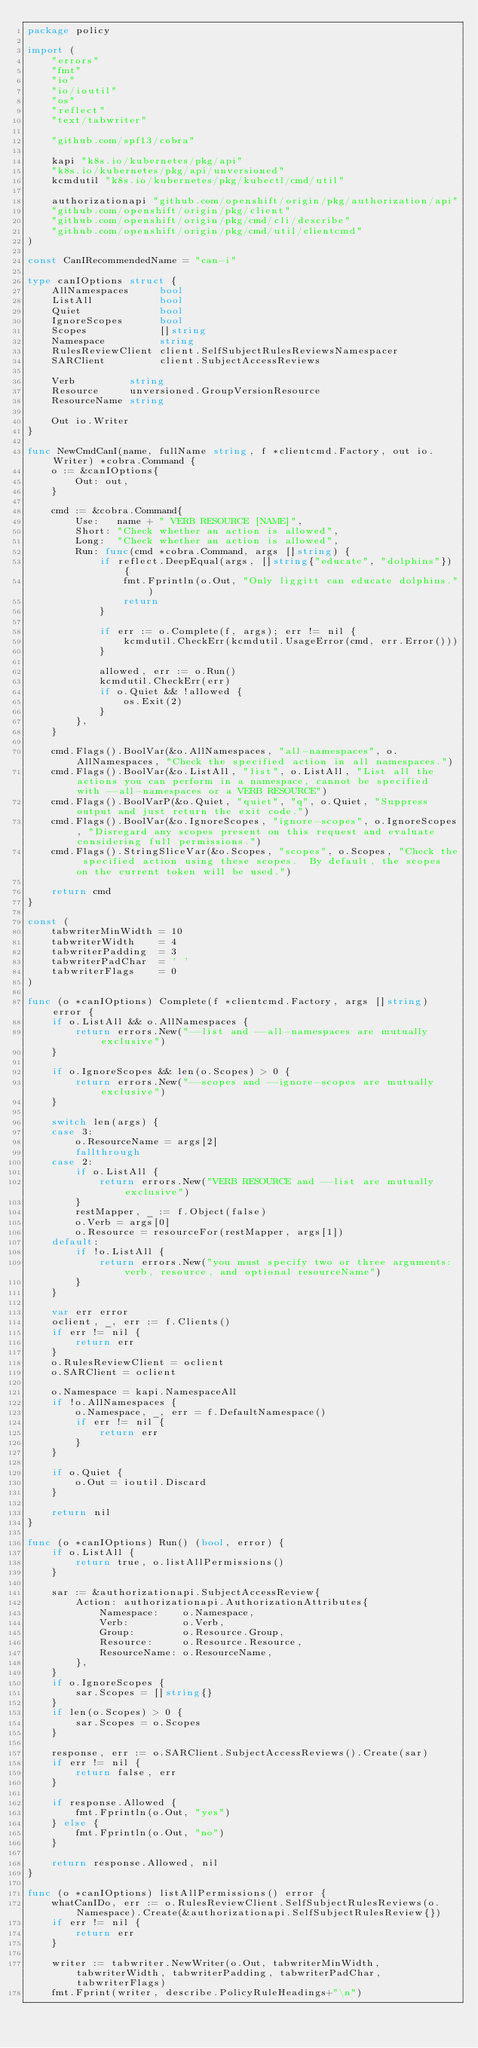<code> <loc_0><loc_0><loc_500><loc_500><_Go_>package policy

import (
	"errors"
	"fmt"
	"io"
	"io/ioutil"
	"os"
	"reflect"
	"text/tabwriter"

	"github.com/spf13/cobra"

	kapi "k8s.io/kubernetes/pkg/api"
	"k8s.io/kubernetes/pkg/api/unversioned"
	kcmdutil "k8s.io/kubernetes/pkg/kubectl/cmd/util"

	authorizationapi "github.com/openshift/origin/pkg/authorization/api"
	"github.com/openshift/origin/pkg/client"
	"github.com/openshift/origin/pkg/cmd/cli/describe"
	"github.com/openshift/origin/pkg/cmd/util/clientcmd"
)

const CanIRecommendedName = "can-i"

type canIOptions struct {
	AllNamespaces     bool
	ListAll           bool
	Quiet             bool
	IgnoreScopes      bool
	Scopes            []string
	Namespace         string
	RulesReviewClient client.SelfSubjectRulesReviewsNamespacer
	SARClient         client.SubjectAccessReviews

	Verb         string
	Resource     unversioned.GroupVersionResource
	ResourceName string

	Out io.Writer
}

func NewCmdCanI(name, fullName string, f *clientcmd.Factory, out io.Writer) *cobra.Command {
	o := &canIOptions{
		Out: out,
	}

	cmd := &cobra.Command{
		Use:   name + " VERB RESOURCE [NAME]",
		Short: "Check whether an action is allowed",
		Long:  "Check whether an action is allowed",
		Run: func(cmd *cobra.Command, args []string) {
			if reflect.DeepEqual(args, []string{"educate", "dolphins"}) {
				fmt.Fprintln(o.Out, "Only liggitt can educate dolphins.")
				return
			}

			if err := o.Complete(f, args); err != nil {
				kcmdutil.CheckErr(kcmdutil.UsageError(cmd, err.Error()))
			}

			allowed, err := o.Run()
			kcmdutil.CheckErr(err)
			if o.Quiet && !allowed {
				os.Exit(2)
			}
		},
	}

	cmd.Flags().BoolVar(&o.AllNamespaces, "all-namespaces", o.AllNamespaces, "Check the specified action in all namespaces.")
	cmd.Flags().BoolVar(&o.ListAll, "list", o.ListAll, "List all the actions you can perform in a namespace, cannot be specified with --all-namespaces or a VERB RESOURCE")
	cmd.Flags().BoolVarP(&o.Quiet, "quiet", "q", o.Quiet, "Suppress output and just return the exit code.")
	cmd.Flags().BoolVar(&o.IgnoreScopes, "ignore-scopes", o.IgnoreScopes, "Disregard any scopes present on this request and evaluate considering full permissions.")
	cmd.Flags().StringSliceVar(&o.Scopes, "scopes", o.Scopes, "Check the specified action using these scopes.  By default, the scopes on the current token will be used.")

	return cmd
}

const (
	tabwriterMinWidth = 10
	tabwriterWidth    = 4
	tabwriterPadding  = 3
	tabwriterPadChar  = ' '
	tabwriterFlags    = 0
)

func (o *canIOptions) Complete(f *clientcmd.Factory, args []string) error {
	if o.ListAll && o.AllNamespaces {
		return errors.New("--list and --all-namespaces are mutually exclusive")
	}

	if o.IgnoreScopes && len(o.Scopes) > 0 {
		return errors.New("--scopes and --ignore-scopes are mutually exclusive")
	}

	switch len(args) {
	case 3:
		o.ResourceName = args[2]
		fallthrough
	case 2:
		if o.ListAll {
			return errors.New("VERB RESOURCE and --list are mutually exclusive")
		}
		restMapper, _ := f.Object(false)
		o.Verb = args[0]
		o.Resource = resourceFor(restMapper, args[1])
	default:
		if !o.ListAll {
			return errors.New("you must specify two or three arguments: verb, resource, and optional resourceName")
		}
	}

	var err error
	oclient, _, err := f.Clients()
	if err != nil {
		return err
	}
	o.RulesReviewClient = oclient
	o.SARClient = oclient

	o.Namespace = kapi.NamespaceAll
	if !o.AllNamespaces {
		o.Namespace, _, err = f.DefaultNamespace()
		if err != nil {
			return err
		}
	}

	if o.Quiet {
		o.Out = ioutil.Discard
	}

	return nil
}

func (o *canIOptions) Run() (bool, error) {
	if o.ListAll {
		return true, o.listAllPermissions()
	}

	sar := &authorizationapi.SubjectAccessReview{
		Action: authorizationapi.AuthorizationAttributes{
			Namespace:    o.Namespace,
			Verb:         o.Verb,
			Group:        o.Resource.Group,
			Resource:     o.Resource.Resource,
			ResourceName: o.ResourceName,
		},
	}
	if o.IgnoreScopes {
		sar.Scopes = []string{}
	}
	if len(o.Scopes) > 0 {
		sar.Scopes = o.Scopes
	}

	response, err := o.SARClient.SubjectAccessReviews().Create(sar)
	if err != nil {
		return false, err
	}

	if response.Allowed {
		fmt.Fprintln(o.Out, "yes")
	} else {
		fmt.Fprintln(o.Out, "no")
	}

	return response.Allowed, nil
}

func (o *canIOptions) listAllPermissions() error {
	whatCanIDo, err := o.RulesReviewClient.SelfSubjectRulesReviews(o.Namespace).Create(&authorizationapi.SelfSubjectRulesReview{})
	if err != nil {
		return err
	}

	writer := tabwriter.NewWriter(o.Out, tabwriterMinWidth, tabwriterWidth, tabwriterPadding, tabwriterPadChar, tabwriterFlags)
	fmt.Fprint(writer, describe.PolicyRuleHeadings+"\n")</code> 